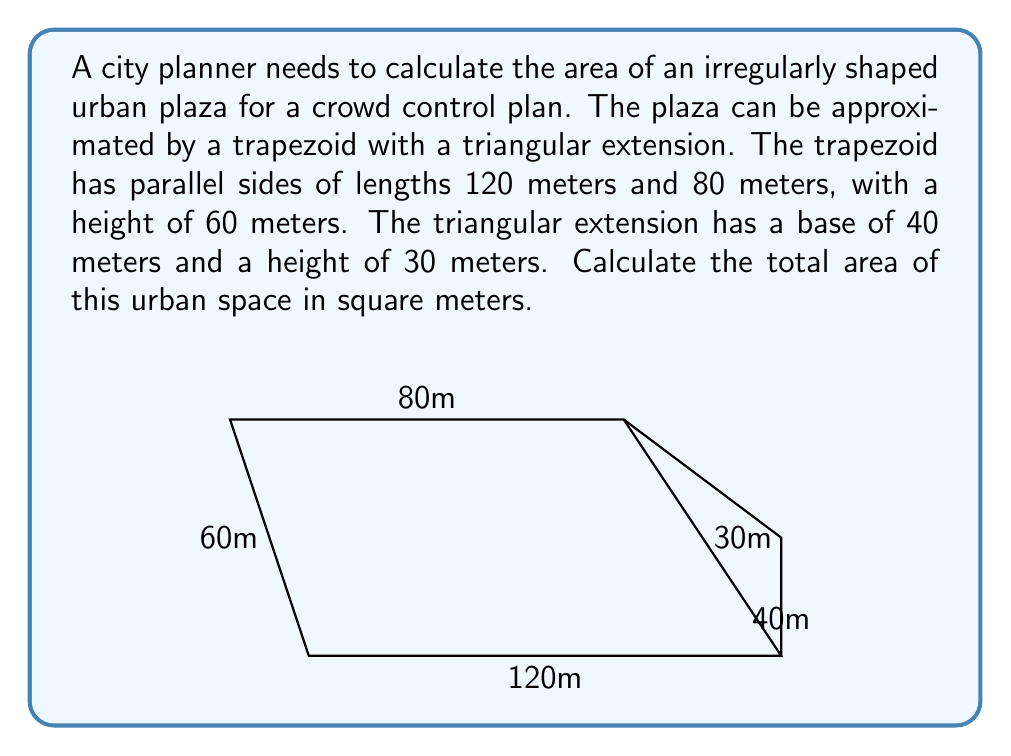Solve this math problem. To solve this problem, we'll calculate the areas of the trapezoid and triangle separately, then sum them up:

1. Area of the trapezoid:
   The formula for the area of a trapezoid is:
   $$A_{trapezoid} = \frac{1}{2}(b_1 + b_2)h$$
   where $b_1$ and $b_2$ are the parallel sides and $h$ is the height.

   $$A_{trapezoid} = \frac{1}{2}(120 + 80) \times 60 = 100 \times 60 = 6000 \text{ m}^2$$

2. Area of the triangle:
   The formula for the area of a triangle is:
   $$A_{triangle} = \frac{1}{2}bh$$
   where $b$ is the base and $h$ is the height.

   $$A_{triangle} = \frac{1}{2} \times 40 \times 30 = 600 \text{ m}^2$$

3. Total area:
   Sum the areas of the trapezoid and triangle:
   $$A_{total} = A_{trapezoid} + A_{triangle} = 6000 + 600 = 6600 \text{ m}^2$$

Therefore, the total area of the urban plaza is 6600 square meters.
Answer: 6600 m² 